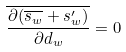<formula> <loc_0><loc_0><loc_500><loc_500>\overline { \frac { \partial ( \overline { s _ { w } } + s _ { w } ^ { \prime } ) } { \partial d _ { w } } } = 0</formula> 